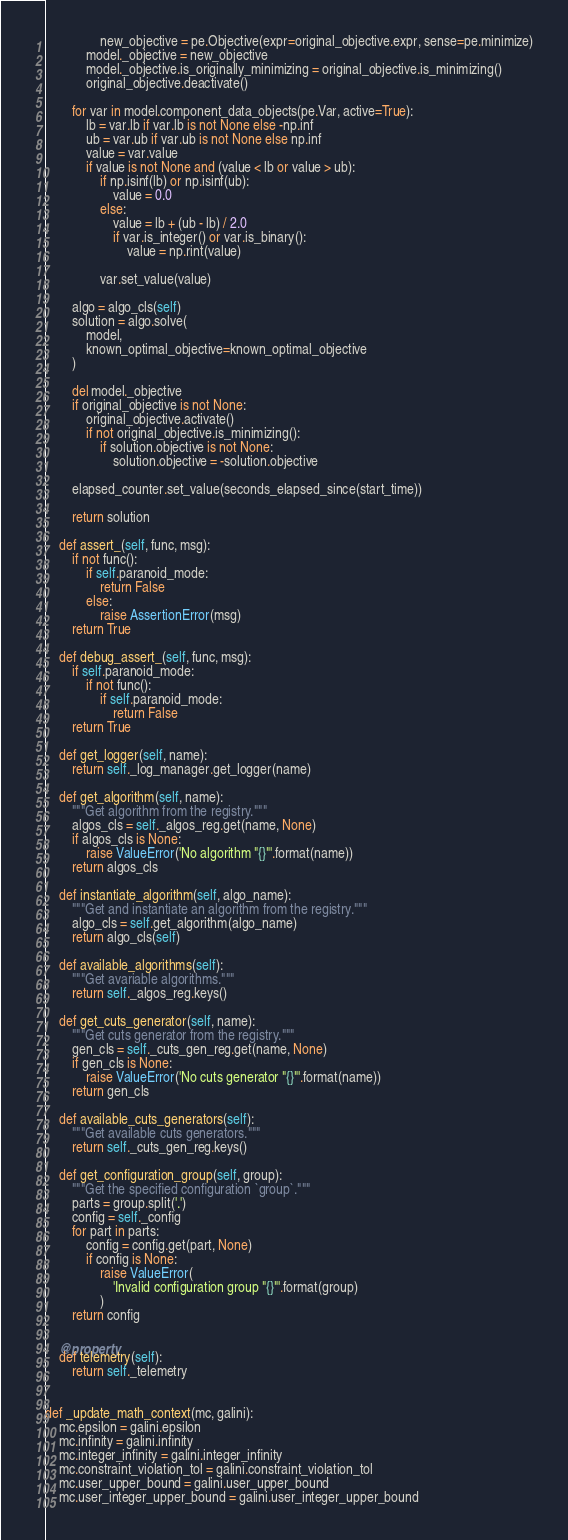<code> <loc_0><loc_0><loc_500><loc_500><_Python_>                new_objective = pe.Objective(expr=original_objective.expr, sense=pe.minimize)
            model._objective = new_objective
            model._objective.is_originally_minimizing = original_objective.is_minimizing()
            original_objective.deactivate()

        for var in model.component_data_objects(pe.Var, active=True):
            lb = var.lb if var.lb is not None else -np.inf
            ub = var.ub if var.ub is not None else np.inf
            value = var.value
            if value is not None and (value < lb or value > ub):
                if np.isinf(lb) or np.isinf(ub):
                    value = 0.0
                else:
                    value = lb + (ub - lb) / 2.0
                    if var.is_integer() or var.is_binary():
                        value = np.rint(value)

                var.set_value(value)

        algo = algo_cls(self)
        solution = algo.solve(
            model,
            known_optimal_objective=known_optimal_objective
        )

        del model._objective
        if original_objective is not None:
            original_objective.activate()
            if not original_objective.is_minimizing():
                if solution.objective is not None:
                    solution.objective = -solution.objective

        elapsed_counter.set_value(seconds_elapsed_since(start_time))

        return solution

    def assert_(self, func, msg):
        if not func():
            if self.paranoid_mode:
                return False
            else:
                raise AssertionError(msg)
        return True

    def debug_assert_(self, func, msg):
        if self.paranoid_mode:
            if not func():
                if self.paranoid_mode:
                    return False
        return True

    def get_logger(self, name):
        return self._log_manager.get_logger(name)

    def get_algorithm(self, name):
        """Get algorithm from the registry."""
        algos_cls = self._algos_reg.get(name, None)
        if algos_cls is None:
            raise ValueError('No algorithm "{}"'.format(name))
        return algos_cls

    def instantiate_algorithm(self, algo_name):
        """Get and instantiate an algorithm from the registry."""
        algo_cls = self.get_algorithm(algo_name)
        return algo_cls(self)

    def available_algorithms(self):
        """Get avariable algorithms."""
        return self._algos_reg.keys()

    def get_cuts_generator(self, name):
        """Get cuts generator from the registry."""
        gen_cls = self._cuts_gen_reg.get(name, None)
        if gen_cls is None:
            raise ValueError('No cuts generator "{}"'.format(name))
        return gen_cls

    def available_cuts_generators(self):
        """Get available cuts generators."""
        return self._cuts_gen_reg.keys()

    def get_configuration_group(self, group):
        """Get the specified configuration `group`."""
        parts = group.split('.')
        config = self._config
        for part in parts:
            config = config.get(part, None)
            if config is None:
                raise ValueError(
                    'Invalid configuration group "{}"'.format(group)
                )
        return config

    @property
    def telemetry(self):
        return self._telemetry


def _update_math_context(mc, galini):
    mc.epsilon = galini.epsilon
    mc.infinity = galini.infinity
    mc.integer_infinity = galini.integer_infinity
    mc.constraint_violation_tol = galini.constraint_violation_tol
    mc.user_upper_bound = galini.user_upper_bound
    mc.user_integer_upper_bound = galini.user_integer_upper_bound
</code> 